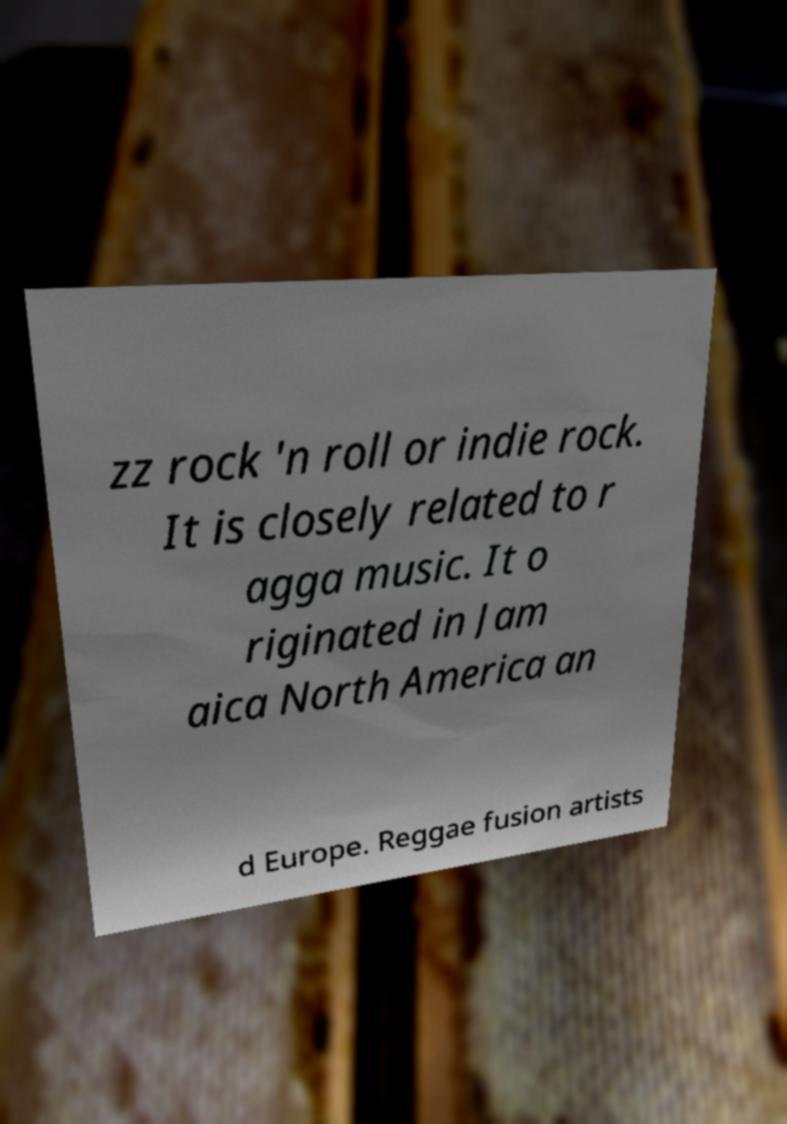Can you accurately transcribe the text from the provided image for me? zz rock 'n roll or indie rock. It is closely related to r agga music. It o riginated in Jam aica North America an d Europe. Reggae fusion artists 